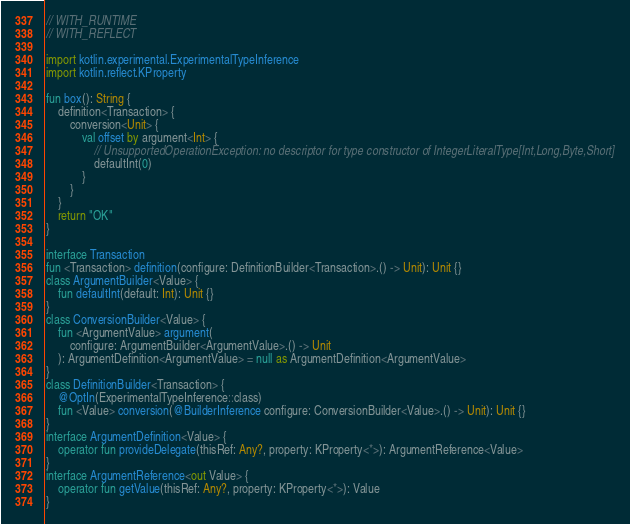Convert code to text. <code><loc_0><loc_0><loc_500><loc_500><_Kotlin_>// WITH_RUNTIME
// WITH_REFLECT

import kotlin.experimental.ExperimentalTypeInference
import kotlin.reflect.KProperty

fun box(): String {
    definition<Transaction> {
        conversion<Unit> {
            val offset by argument<Int> {
                // UnsupportedOperationException: no descriptor for type constructor of IntegerLiteralType[Int,Long,Byte,Short]
                defaultInt(0)
            }
        }
    }
    return "OK"
}

interface Transaction
fun <Transaction> definition(configure: DefinitionBuilder<Transaction>.() -> Unit): Unit {}
class ArgumentBuilder<Value> {
    fun defaultInt(default: Int): Unit {}
}
class ConversionBuilder<Value> {
    fun <ArgumentValue> argument(
        configure: ArgumentBuilder<ArgumentValue>.() -> Unit
    ): ArgumentDefinition<ArgumentValue> = null as ArgumentDefinition<ArgumentValue>
}
class DefinitionBuilder<Transaction> {
    @OptIn(ExperimentalTypeInference::class)
    fun <Value> conversion(@BuilderInference configure: ConversionBuilder<Value>.() -> Unit): Unit {}
}
interface ArgumentDefinition<Value> {
    operator fun provideDelegate(thisRef: Any?, property: KProperty<*>): ArgumentReference<Value>
}
interface ArgumentReference<out Value> {
    operator fun getValue(thisRef: Any?, property: KProperty<*>): Value
}
</code> 